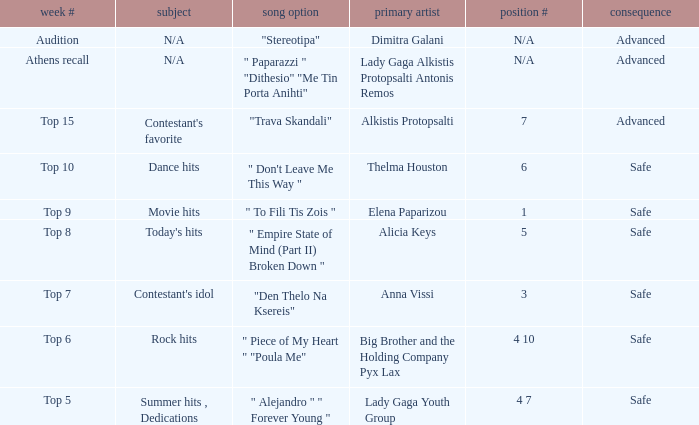Which artists possess order number 6? Thelma Houston. 